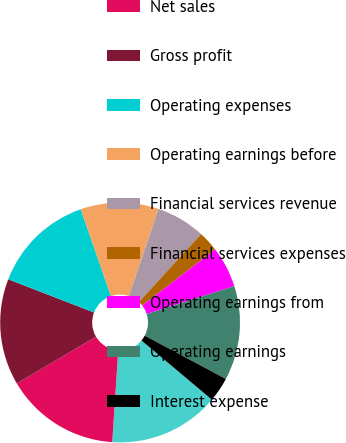Convert chart. <chart><loc_0><loc_0><loc_500><loc_500><pie_chart><fcel>Five-year Data (Amounts in<fcel>Net sales<fcel>Gross profit<fcel>Operating expenses<fcel>Operating earnings before<fcel>Financial services revenue<fcel>Financial services expenses<fcel>Operating earnings from<fcel>Operating earnings<fcel>Interest expense<nl><fcel>14.92%<fcel>15.47%<fcel>14.36%<fcel>13.81%<fcel>10.5%<fcel>6.63%<fcel>2.76%<fcel>5.53%<fcel>12.71%<fcel>3.32%<nl></chart> 